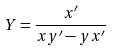<formula> <loc_0><loc_0><loc_500><loc_500>Y = \frac { x ^ { \prime } } { x y ^ { \prime } - y x ^ { \prime } }</formula> 